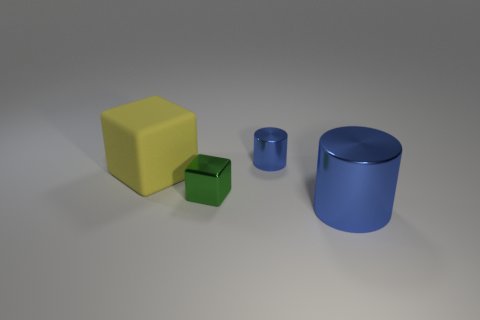There is a blue object that is behind the large blue metal cylinder; what is it made of?
Ensure brevity in your answer.  Metal. The tiny cylinder has what color?
Keep it short and to the point. Blue. There is a blue cylinder that is behind the big shiny object; does it have the same size as the yellow rubber object that is behind the big blue thing?
Offer a very short reply. No. There is a object that is behind the tiny metallic cube and on the right side of the shiny cube; what is its size?
Provide a short and direct response. Small. There is another matte object that is the same shape as the small green object; what color is it?
Provide a short and direct response. Yellow. Are there more matte things in front of the big cylinder than metallic cylinders on the left side of the shiny cube?
Provide a succinct answer. No. How many other objects are there of the same shape as the big yellow thing?
Offer a terse response. 1. Is there a big blue cylinder that is on the right side of the blue metal object in front of the tiny cylinder?
Offer a very short reply. No. What number of small gray metal objects are there?
Your answer should be very brief. 0. There is a small cylinder; is it the same color as the large thing left of the big metal thing?
Your answer should be very brief. No. 